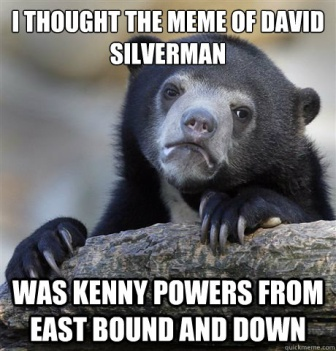Where might this bear be found in the wild? This black bear could be found in a variety of wild habitats across North America, including forests, mountains, and sometimes even near human settlements. They are known to be quite adaptable to different environments. 